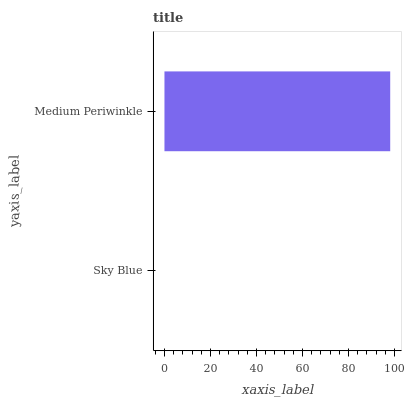Is Sky Blue the minimum?
Answer yes or no. Yes. Is Medium Periwinkle the maximum?
Answer yes or no. Yes. Is Medium Periwinkle the minimum?
Answer yes or no. No. Is Medium Periwinkle greater than Sky Blue?
Answer yes or no. Yes. Is Sky Blue less than Medium Periwinkle?
Answer yes or no. Yes. Is Sky Blue greater than Medium Periwinkle?
Answer yes or no. No. Is Medium Periwinkle less than Sky Blue?
Answer yes or no. No. Is Medium Periwinkle the high median?
Answer yes or no. Yes. Is Sky Blue the low median?
Answer yes or no. Yes. Is Sky Blue the high median?
Answer yes or no. No. Is Medium Periwinkle the low median?
Answer yes or no. No. 